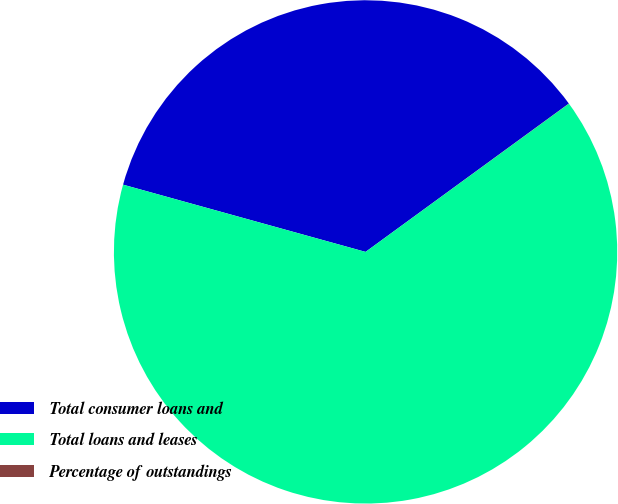Convert chart to OTSL. <chart><loc_0><loc_0><loc_500><loc_500><pie_chart><fcel>Total consumer loans and<fcel>Total loans and leases<fcel>Percentage of outstandings<nl><fcel>35.66%<fcel>64.33%<fcel>0.01%<nl></chart> 